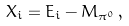Convert formula to latex. <formula><loc_0><loc_0><loc_500><loc_500>X _ { i } = E _ { i } - M _ { \pi ^ { 0 } } \, ,</formula> 